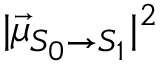Convert formula to latex. <formula><loc_0><loc_0><loc_500><loc_500>| \vec { \mu } _ { S _ { 0 } \rightarrow S _ { 1 } } | ^ { 2 }</formula> 